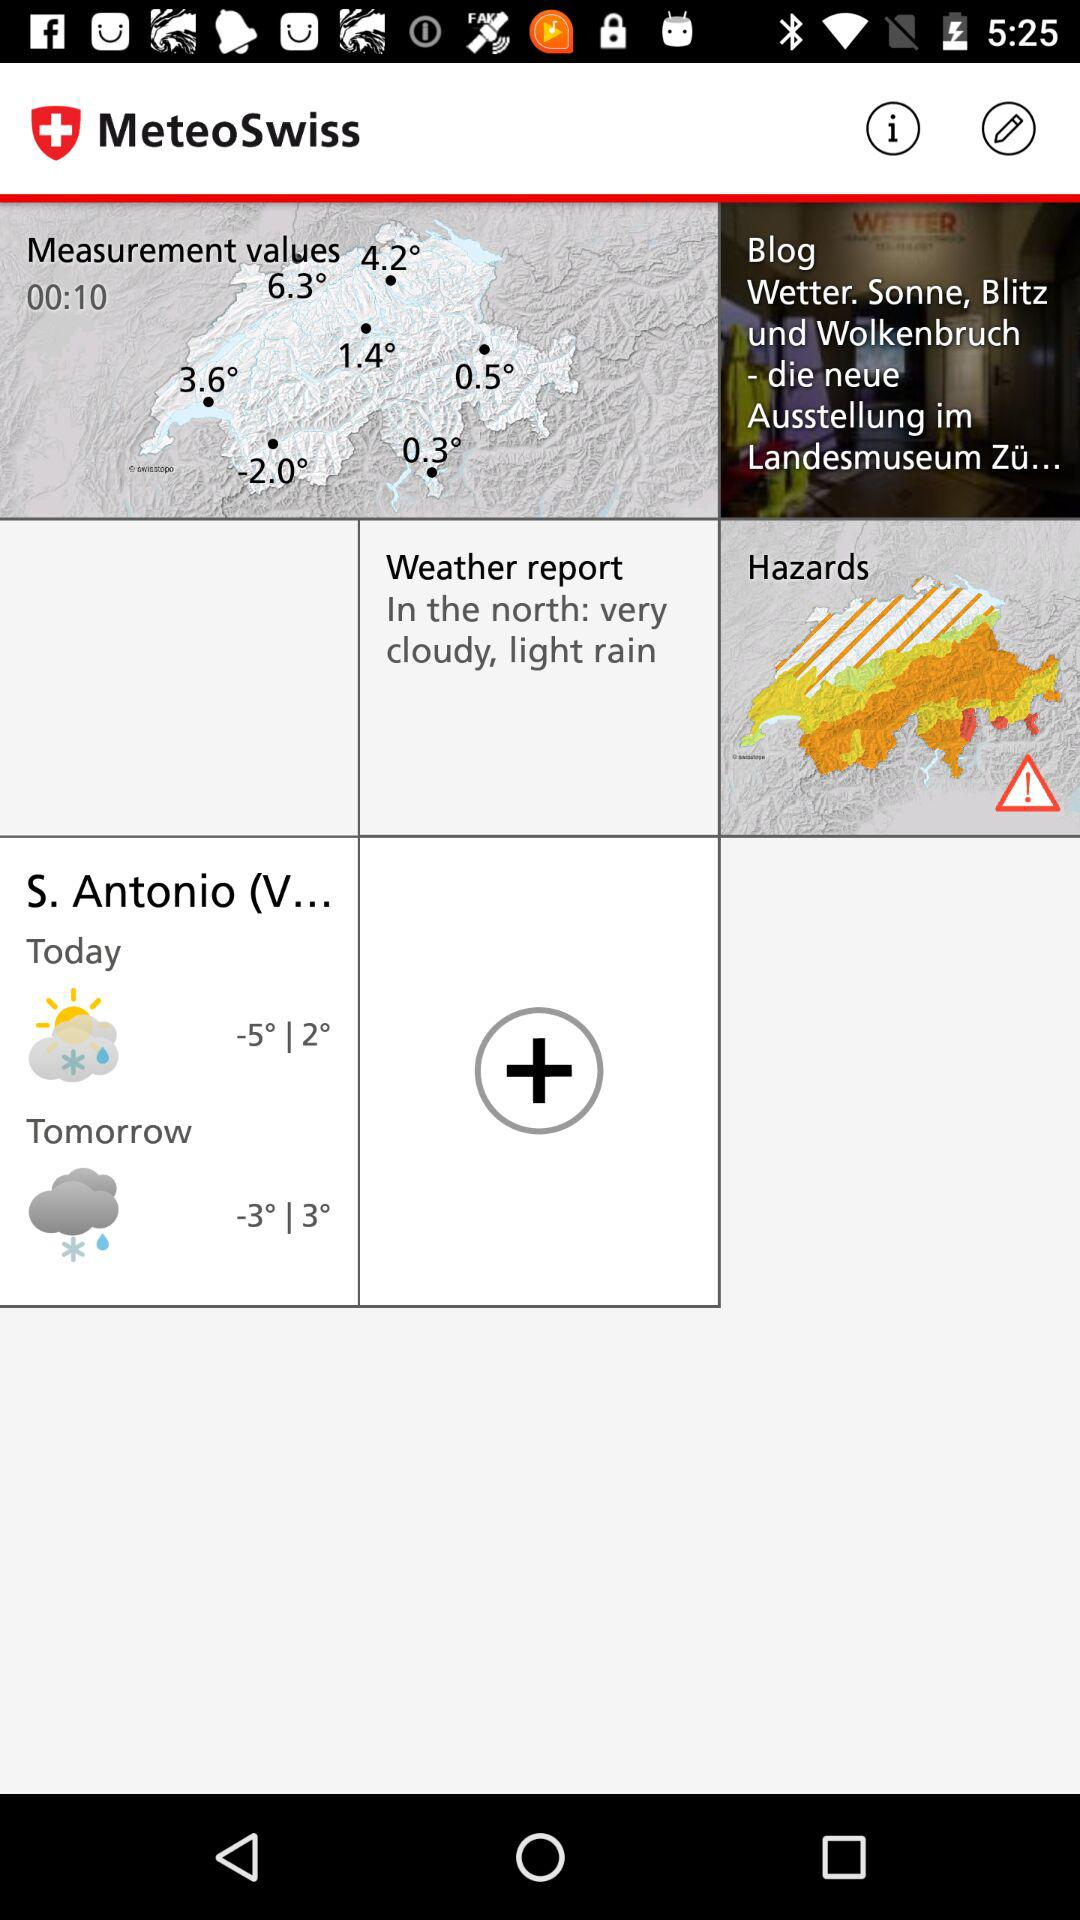What is the name of the application? The name of the application is "MeteoSwiss". 